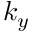Convert formula to latex. <formula><loc_0><loc_0><loc_500><loc_500>k _ { y }</formula> 